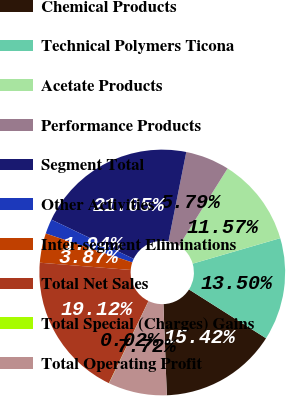<chart> <loc_0><loc_0><loc_500><loc_500><pie_chart><fcel>Chemical Products<fcel>Technical Polymers Ticona<fcel>Acetate Products<fcel>Performance Products<fcel>Segment Total<fcel>Other Activities<fcel>Inter-segment Eliminations<fcel>Total Net Sales<fcel>Total Special (Charges) Gains<fcel>Total Operating Profit<nl><fcel>15.42%<fcel>13.5%<fcel>11.57%<fcel>5.79%<fcel>21.05%<fcel>1.94%<fcel>3.87%<fcel>19.12%<fcel>0.02%<fcel>7.72%<nl></chart> 